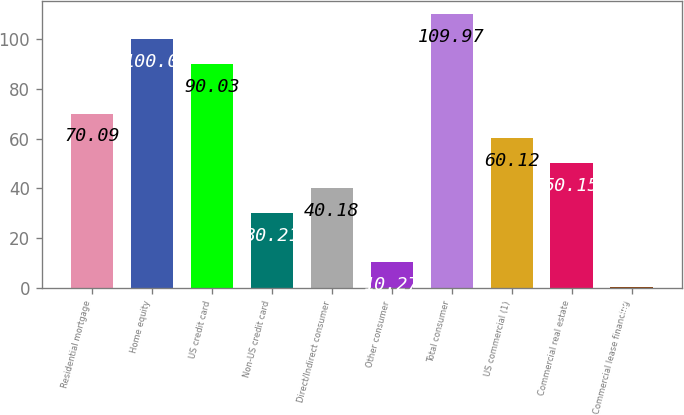<chart> <loc_0><loc_0><loc_500><loc_500><bar_chart><fcel>Residential mortgage<fcel>Home equity<fcel>US credit card<fcel>Non-US credit card<fcel>Direct/Indirect consumer<fcel>Other consumer<fcel>Total consumer<fcel>US commercial (1)<fcel>Commercial real estate<fcel>Commercial lease financing<nl><fcel>70.09<fcel>100<fcel>90.03<fcel>30.21<fcel>40.18<fcel>10.27<fcel>109.97<fcel>60.12<fcel>50.15<fcel>0.3<nl></chart> 